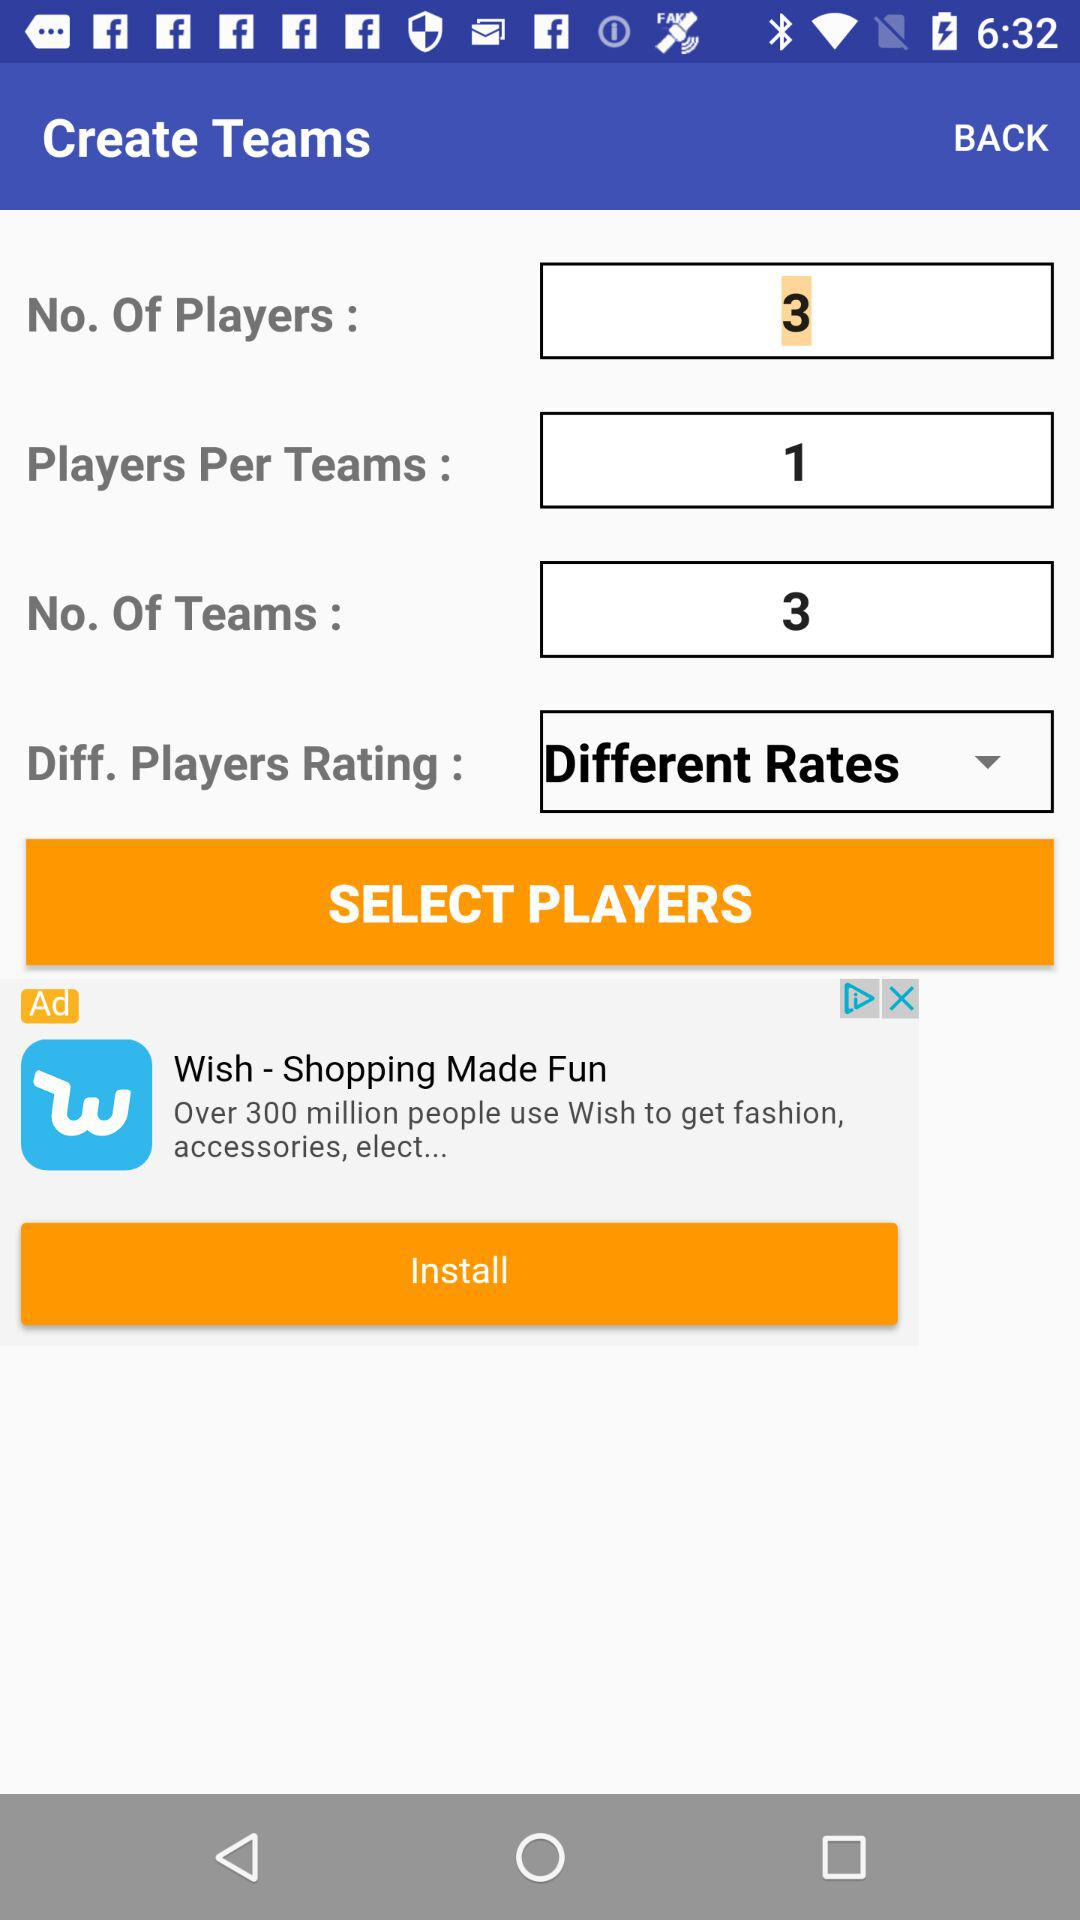What is the number of players? The number of players is 3. 